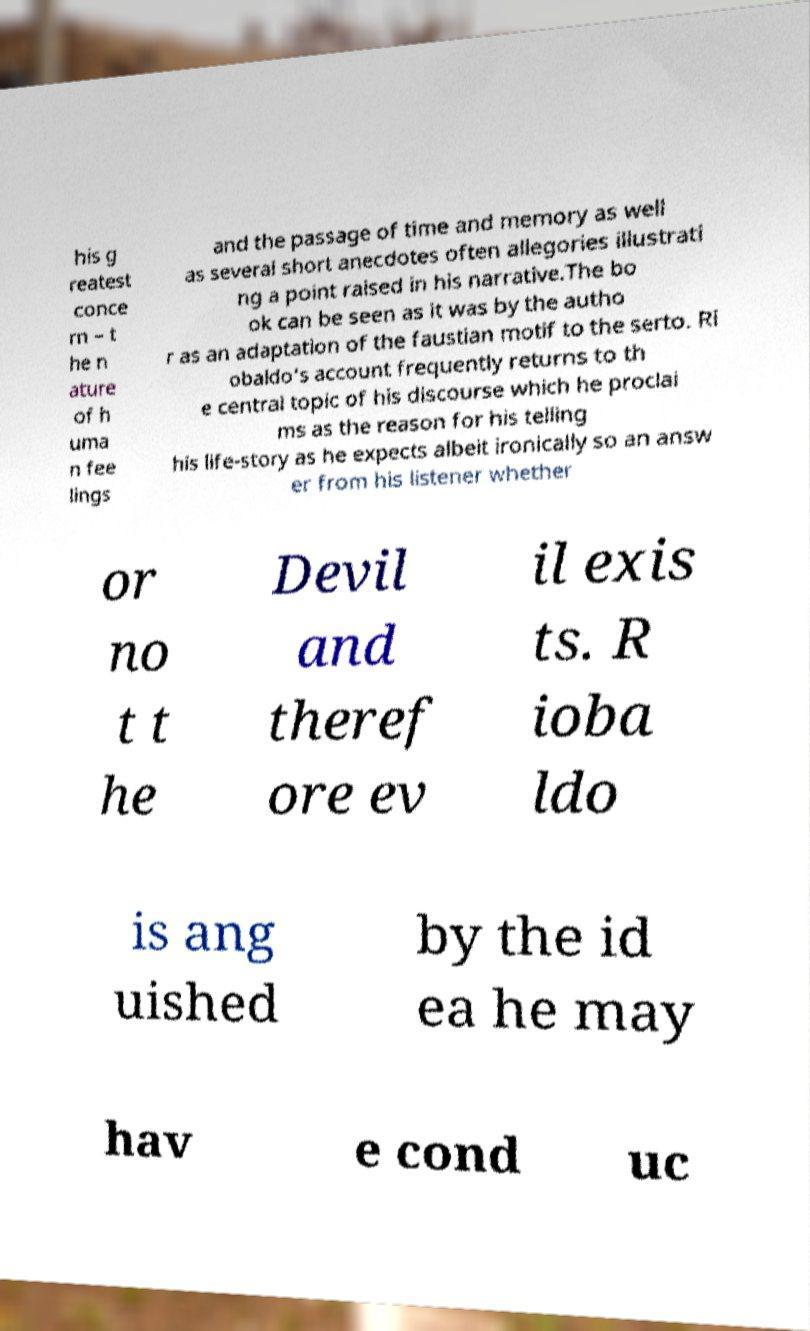Please identify and transcribe the text found in this image. his g reatest conce rn – t he n ature of h uma n fee lings and the passage of time and memory as well as several short anecdotes often allegories illustrati ng a point raised in his narrative.The bo ok can be seen as it was by the autho r as an adaptation of the faustian motif to the serto. Ri obaldo's account frequently returns to th e central topic of his discourse which he proclai ms as the reason for his telling his life-story as he expects albeit ironically so an answ er from his listener whether or no t t he Devil and theref ore ev il exis ts. R ioba ldo is ang uished by the id ea he may hav e cond uc 